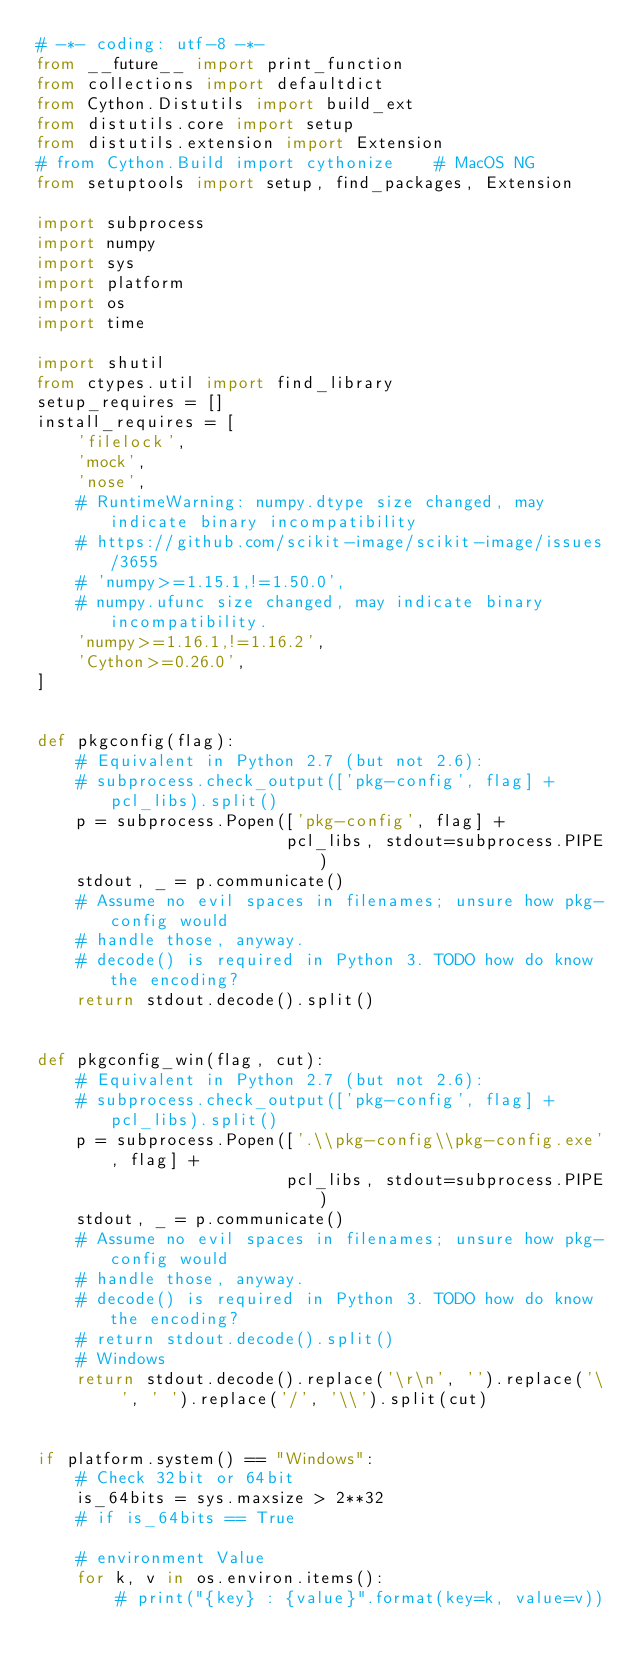Convert code to text. <code><loc_0><loc_0><loc_500><loc_500><_Python_># -*- coding: utf-8 -*-
from __future__ import print_function
from collections import defaultdict
from Cython.Distutils import build_ext
from distutils.core import setup
from distutils.extension import Extension
# from Cython.Build import cythonize    # MacOS NG
from setuptools import setup, find_packages, Extension

import subprocess
import numpy
import sys
import platform
import os
import time

import shutil
from ctypes.util import find_library
setup_requires = []
install_requires = [
    'filelock',
    'mock',
    'nose',
    # RuntimeWarning: numpy.dtype size changed, may indicate binary incompatibility
    # https://github.com/scikit-image/scikit-image/issues/3655
    # 'numpy>=1.15.1,!=1.50.0',
    # numpy.ufunc size changed, may indicate binary incompatibility. 
    'numpy>=1.16.1,!=1.16.2',
    'Cython>=0.26.0',
]


def pkgconfig(flag):
    # Equivalent in Python 2.7 (but not 2.6):
    # subprocess.check_output(['pkg-config', flag] + pcl_libs).split()
    p = subprocess.Popen(['pkg-config', flag] +
                         pcl_libs, stdout=subprocess.PIPE)
    stdout, _ = p.communicate()
    # Assume no evil spaces in filenames; unsure how pkg-config would
    # handle those, anyway.
    # decode() is required in Python 3. TODO how do know the encoding?
    return stdout.decode().split()


def pkgconfig_win(flag, cut):
    # Equivalent in Python 2.7 (but not 2.6):
    # subprocess.check_output(['pkg-config', flag] + pcl_libs).split()
    p = subprocess.Popen(['.\\pkg-config\\pkg-config.exe', flag] +
                         pcl_libs, stdout=subprocess.PIPE)
    stdout, _ = p.communicate()
    # Assume no evil spaces in filenames; unsure how pkg-config would
    # handle those, anyway.
    # decode() is required in Python 3. TODO how do know the encoding?
    # return stdout.decode().split()
    # Windows
    return stdout.decode().replace('\r\n', '').replace('\ ', ' ').replace('/', '\\').split(cut)


if platform.system() == "Windows":
    # Check 32bit or 64bit
    is_64bits = sys.maxsize > 2**32
    # if is_64bits == True

    # environment Value
    for k, v in os.environ.items():
        # print("{key} : {value}".format(key=k, value=v))</code> 